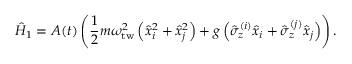<formula> <loc_0><loc_0><loc_500><loc_500>\hat { H } _ { 1 } = A ( t ) \left ( \frac { 1 } { 2 } m \omega _ { t w } ^ { 2 } \left ( \hat { x } _ { i } ^ { 2 } + \hat { x } _ { j } ^ { 2 } \right ) + g \left ( \hat { \sigma } _ { z } ^ { ( i ) } \hat { x } _ { i } + \hat { \sigma } _ { z } ^ { ( j ) } \hat { x } _ { j } \right ) \right ) .</formula> 